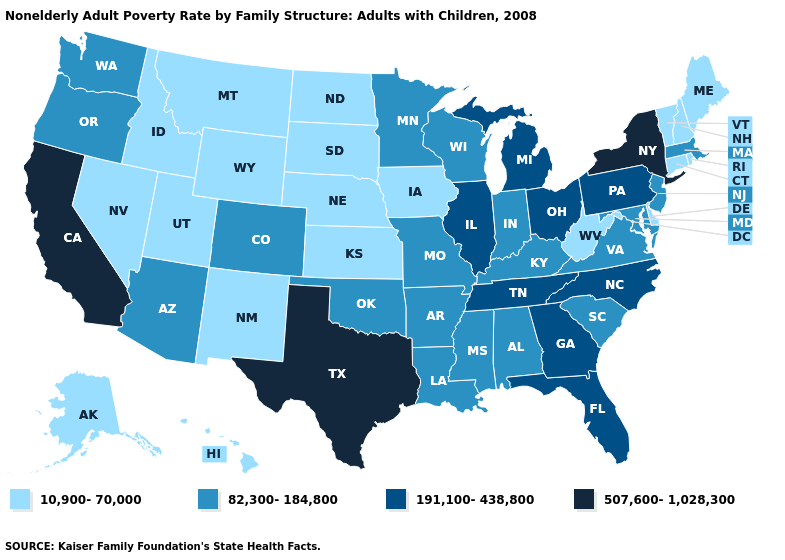Does South Dakota have the same value as Hawaii?
Quick response, please. Yes. Does Michigan have a lower value than Virginia?
Keep it brief. No. Among the states that border Vermont , does New York have the lowest value?
Short answer required. No. How many symbols are there in the legend?
Concise answer only. 4. How many symbols are there in the legend?
Short answer required. 4. Name the states that have a value in the range 507,600-1,028,300?
Quick response, please. California, New York, Texas. What is the lowest value in the Northeast?
Be succinct. 10,900-70,000. Name the states that have a value in the range 191,100-438,800?
Write a very short answer. Florida, Georgia, Illinois, Michigan, North Carolina, Ohio, Pennsylvania, Tennessee. Does New York have the highest value in the Northeast?
Keep it brief. Yes. Among the states that border Idaho , does Washington have the lowest value?
Keep it brief. No. Does Maine have the highest value in the Northeast?
Concise answer only. No. Name the states that have a value in the range 191,100-438,800?
Write a very short answer. Florida, Georgia, Illinois, Michigan, North Carolina, Ohio, Pennsylvania, Tennessee. Which states have the lowest value in the South?
Quick response, please. Delaware, West Virginia. Among the states that border North Dakota , does Minnesota have the highest value?
Short answer required. Yes. Does Ohio have the highest value in the MidWest?
Keep it brief. Yes. 